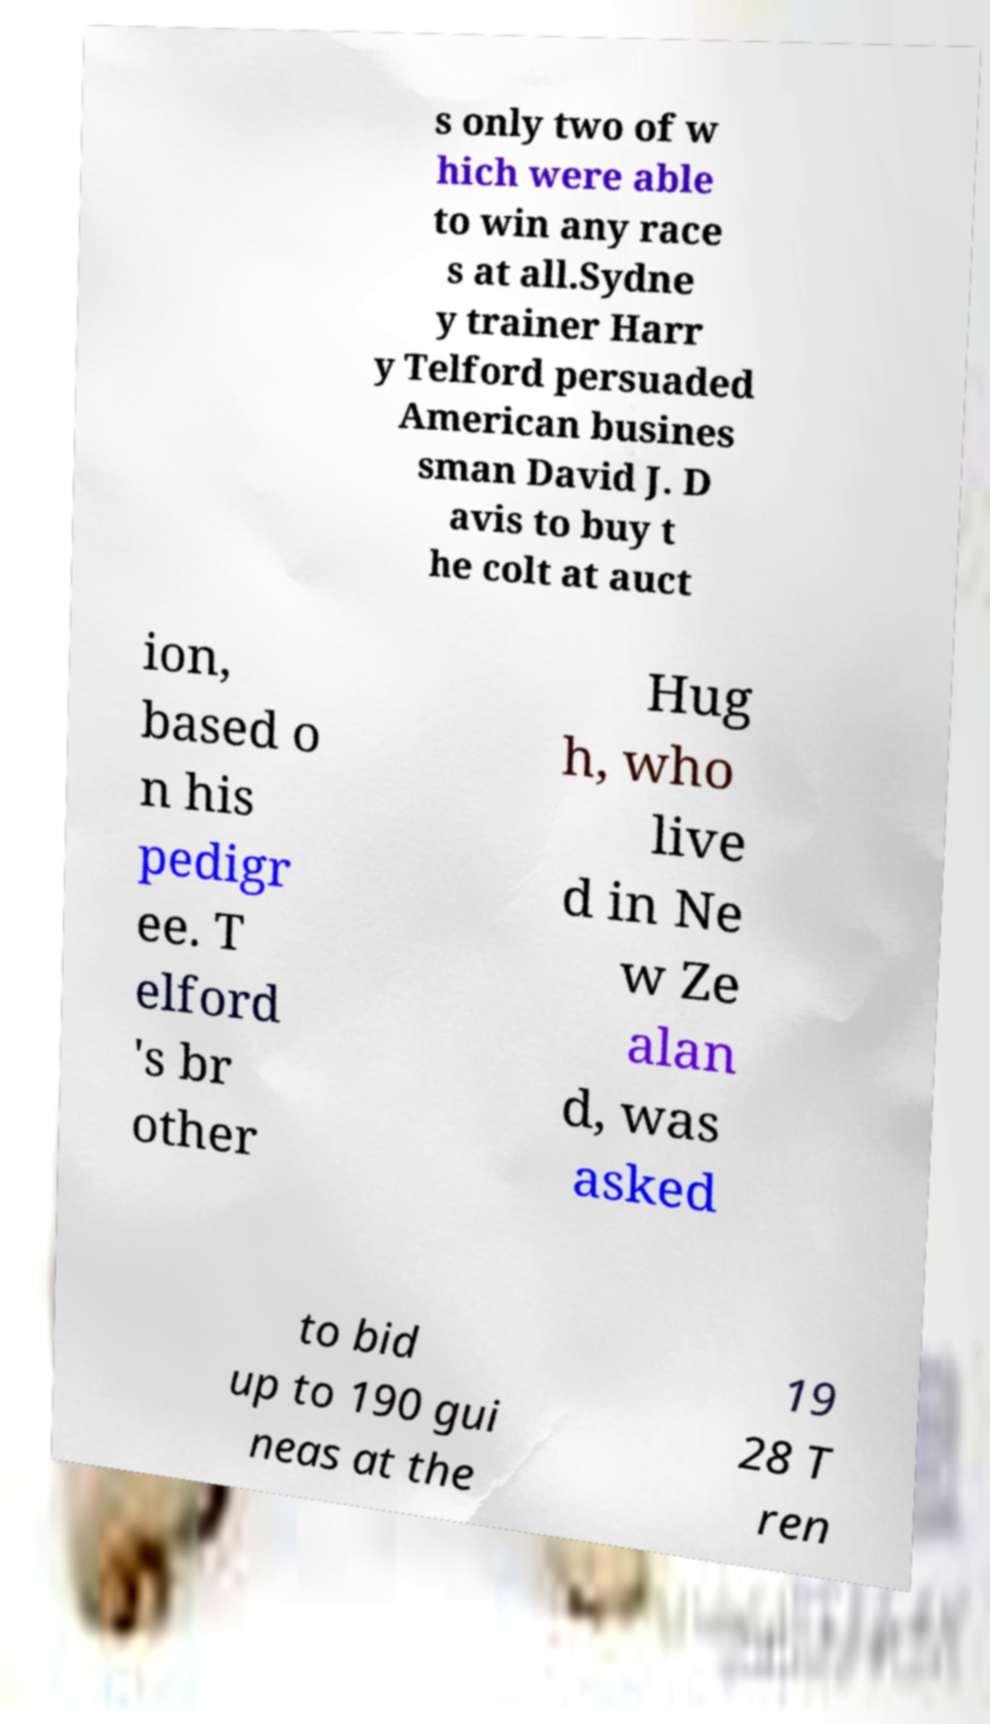Could you extract and type out the text from this image? s only two of w hich were able to win any race s at all.Sydne y trainer Harr y Telford persuaded American busines sman David J. D avis to buy t he colt at auct ion, based o n his pedigr ee. T elford 's br other Hug h, who live d in Ne w Ze alan d, was asked to bid up to 190 gui neas at the 19 28 T ren 